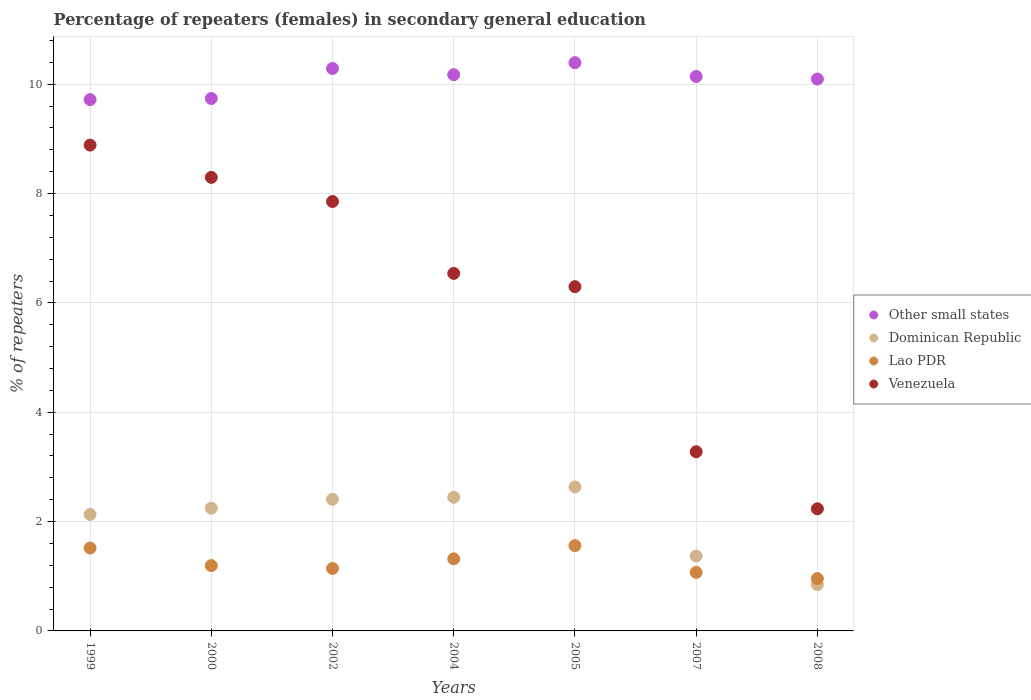How many different coloured dotlines are there?
Make the answer very short. 4. What is the percentage of female repeaters in Other small states in 2007?
Offer a terse response. 10.14. Across all years, what is the maximum percentage of female repeaters in Venezuela?
Your answer should be very brief. 8.89. Across all years, what is the minimum percentage of female repeaters in Lao PDR?
Ensure brevity in your answer.  0.96. In which year was the percentage of female repeaters in Dominican Republic maximum?
Keep it short and to the point. 2005. In which year was the percentage of female repeaters in Lao PDR minimum?
Provide a short and direct response. 2008. What is the total percentage of female repeaters in Dominican Republic in the graph?
Offer a terse response. 14.08. What is the difference between the percentage of female repeaters in Lao PDR in 1999 and that in 2007?
Your answer should be compact. 0.45. What is the difference between the percentage of female repeaters in Lao PDR in 2000 and the percentage of female repeaters in Dominican Republic in 2008?
Give a very brief answer. 0.35. What is the average percentage of female repeaters in Other small states per year?
Offer a very short reply. 10.08. In the year 1999, what is the difference between the percentage of female repeaters in Venezuela and percentage of female repeaters in Dominican Republic?
Your answer should be compact. 6.76. What is the ratio of the percentage of female repeaters in Dominican Republic in 2002 to that in 2004?
Give a very brief answer. 0.99. Is the percentage of female repeaters in Venezuela in 2000 less than that in 2005?
Your answer should be very brief. No. What is the difference between the highest and the second highest percentage of female repeaters in Other small states?
Your answer should be very brief. 0.11. What is the difference between the highest and the lowest percentage of female repeaters in Other small states?
Make the answer very short. 0.68. In how many years, is the percentage of female repeaters in Other small states greater than the average percentage of female repeaters in Other small states taken over all years?
Offer a terse response. 5. Is the sum of the percentage of female repeaters in Venezuela in 2002 and 2007 greater than the maximum percentage of female repeaters in Dominican Republic across all years?
Give a very brief answer. Yes. Is it the case that in every year, the sum of the percentage of female repeaters in Other small states and percentage of female repeaters in Lao PDR  is greater than the sum of percentage of female repeaters in Venezuela and percentage of female repeaters in Dominican Republic?
Your answer should be very brief. Yes. Is it the case that in every year, the sum of the percentage of female repeaters in Lao PDR and percentage of female repeaters in Dominican Republic  is greater than the percentage of female repeaters in Other small states?
Offer a terse response. No. Is the percentage of female repeaters in Venezuela strictly less than the percentage of female repeaters in Other small states over the years?
Ensure brevity in your answer.  Yes. How many years are there in the graph?
Your answer should be very brief. 7. Does the graph contain any zero values?
Your answer should be very brief. No. Does the graph contain grids?
Ensure brevity in your answer.  Yes. Where does the legend appear in the graph?
Provide a short and direct response. Center right. How are the legend labels stacked?
Make the answer very short. Vertical. What is the title of the graph?
Your answer should be very brief. Percentage of repeaters (females) in secondary general education. What is the label or title of the Y-axis?
Your answer should be compact. % of repeaters. What is the % of repeaters of Other small states in 1999?
Offer a terse response. 9.72. What is the % of repeaters in Dominican Republic in 1999?
Keep it short and to the point. 2.13. What is the % of repeaters in Lao PDR in 1999?
Ensure brevity in your answer.  1.52. What is the % of repeaters in Venezuela in 1999?
Make the answer very short. 8.89. What is the % of repeaters of Other small states in 2000?
Your response must be concise. 9.74. What is the % of repeaters in Dominican Republic in 2000?
Offer a terse response. 2.24. What is the % of repeaters of Lao PDR in 2000?
Ensure brevity in your answer.  1.2. What is the % of repeaters of Venezuela in 2000?
Provide a short and direct response. 8.3. What is the % of repeaters in Other small states in 2002?
Your response must be concise. 10.29. What is the % of repeaters of Dominican Republic in 2002?
Ensure brevity in your answer.  2.41. What is the % of repeaters of Lao PDR in 2002?
Offer a terse response. 1.14. What is the % of repeaters of Venezuela in 2002?
Make the answer very short. 7.85. What is the % of repeaters of Other small states in 2004?
Make the answer very short. 10.17. What is the % of repeaters of Dominican Republic in 2004?
Give a very brief answer. 2.44. What is the % of repeaters of Lao PDR in 2004?
Offer a very short reply. 1.32. What is the % of repeaters in Venezuela in 2004?
Offer a very short reply. 6.54. What is the % of repeaters of Other small states in 2005?
Your response must be concise. 10.39. What is the % of repeaters in Dominican Republic in 2005?
Provide a succinct answer. 2.63. What is the % of repeaters in Lao PDR in 2005?
Provide a succinct answer. 1.56. What is the % of repeaters of Venezuela in 2005?
Offer a terse response. 6.3. What is the % of repeaters of Other small states in 2007?
Ensure brevity in your answer.  10.14. What is the % of repeaters in Dominican Republic in 2007?
Provide a succinct answer. 1.37. What is the % of repeaters of Lao PDR in 2007?
Give a very brief answer. 1.07. What is the % of repeaters of Venezuela in 2007?
Offer a very short reply. 3.28. What is the % of repeaters of Other small states in 2008?
Offer a very short reply. 10.09. What is the % of repeaters of Dominican Republic in 2008?
Provide a succinct answer. 0.85. What is the % of repeaters in Lao PDR in 2008?
Make the answer very short. 0.96. What is the % of repeaters in Venezuela in 2008?
Make the answer very short. 2.23. Across all years, what is the maximum % of repeaters in Other small states?
Make the answer very short. 10.39. Across all years, what is the maximum % of repeaters in Dominican Republic?
Your response must be concise. 2.63. Across all years, what is the maximum % of repeaters in Lao PDR?
Ensure brevity in your answer.  1.56. Across all years, what is the maximum % of repeaters in Venezuela?
Keep it short and to the point. 8.89. Across all years, what is the minimum % of repeaters in Other small states?
Give a very brief answer. 9.72. Across all years, what is the minimum % of repeaters in Dominican Republic?
Offer a very short reply. 0.85. Across all years, what is the minimum % of repeaters in Lao PDR?
Your response must be concise. 0.96. Across all years, what is the minimum % of repeaters in Venezuela?
Your answer should be very brief. 2.23. What is the total % of repeaters in Other small states in the graph?
Give a very brief answer. 70.55. What is the total % of repeaters in Dominican Republic in the graph?
Offer a terse response. 14.08. What is the total % of repeaters of Lao PDR in the graph?
Keep it short and to the point. 8.76. What is the total % of repeaters in Venezuela in the graph?
Offer a very short reply. 43.38. What is the difference between the % of repeaters in Other small states in 1999 and that in 2000?
Your answer should be compact. -0.02. What is the difference between the % of repeaters in Dominican Republic in 1999 and that in 2000?
Offer a very short reply. -0.12. What is the difference between the % of repeaters in Lao PDR in 1999 and that in 2000?
Offer a terse response. 0.32. What is the difference between the % of repeaters in Venezuela in 1999 and that in 2000?
Offer a terse response. 0.59. What is the difference between the % of repeaters of Other small states in 1999 and that in 2002?
Your response must be concise. -0.57. What is the difference between the % of repeaters of Dominican Republic in 1999 and that in 2002?
Keep it short and to the point. -0.28. What is the difference between the % of repeaters of Lao PDR in 1999 and that in 2002?
Your answer should be very brief. 0.37. What is the difference between the % of repeaters of Venezuela in 1999 and that in 2002?
Your answer should be very brief. 1.03. What is the difference between the % of repeaters of Other small states in 1999 and that in 2004?
Offer a terse response. -0.46. What is the difference between the % of repeaters in Dominican Republic in 1999 and that in 2004?
Make the answer very short. -0.31. What is the difference between the % of repeaters in Lao PDR in 1999 and that in 2004?
Provide a succinct answer. 0.2. What is the difference between the % of repeaters in Venezuela in 1999 and that in 2004?
Offer a terse response. 2.35. What is the difference between the % of repeaters of Other small states in 1999 and that in 2005?
Offer a very short reply. -0.68. What is the difference between the % of repeaters in Dominican Republic in 1999 and that in 2005?
Your answer should be compact. -0.5. What is the difference between the % of repeaters in Lao PDR in 1999 and that in 2005?
Make the answer very short. -0.05. What is the difference between the % of repeaters in Venezuela in 1999 and that in 2005?
Offer a terse response. 2.59. What is the difference between the % of repeaters of Other small states in 1999 and that in 2007?
Offer a very short reply. -0.42. What is the difference between the % of repeaters in Dominican Republic in 1999 and that in 2007?
Offer a terse response. 0.76. What is the difference between the % of repeaters in Lao PDR in 1999 and that in 2007?
Give a very brief answer. 0.45. What is the difference between the % of repeaters in Venezuela in 1999 and that in 2007?
Your response must be concise. 5.61. What is the difference between the % of repeaters in Other small states in 1999 and that in 2008?
Your response must be concise. -0.38. What is the difference between the % of repeaters of Dominican Republic in 1999 and that in 2008?
Keep it short and to the point. 1.28. What is the difference between the % of repeaters in Lao PDR in 1999 and that in 2008?
Your answer should be compact. 0.56. What is the difference between the % of repeaters of Venezuela in 1999 and that in 2008?
Offer a terse response. 6.65. What is the difference between the % of repeaters of Other small states in 2000 and that in 2002?
Offer a terse response. -0.55. What is the difference between the % of repeaters in Dominican Republic in 2000 and that in 2002?
Make the answer very short. -0.16. What is the difference between the % of repeaters of Lao PDR in 2000 and that in 2002?
Provide a succinct answer. 0.05. What is the difference between the % of repeaters in Venezuela in 2000 and that in 2002?
Provide a short and direct response. 0.44. What is the difference between the % of repeaters of Other small states in 2000 and that in 2004?
Your answer should be very brief. -0.43. What is the difference between the % of repeaters in Dominican Republic in 2000 and that in 2004?
Make the answer very short. -0.2. What is the difference between the % of repeaters in Lao PDR in 2000 and that in 2004?
Offer a very short reply. -0.12. What is the difference between the % of repeaters of Venezuela in 2000 and that in 2004?
Offer a very short reply. 1.76. What is the difference between the % of repeaters of Other small states in 2000 and that in 2005?
Your answer should be compact. -0.65. What is the difference between the % of repeaters in Dominican Republic in 2000 and that in 2005?
Your answer should be very brief. -0.39. What is the difference between the % of repeaters in Lao PDR in 2000 and that in 2005?
Provide a succinct answer. -0.37. What is the difference between the % of repeaters of Venezuela in 2000 and that in 2005?
Offer a terse response. 2. What is the difference between the % of repeaters in Other small states in 2000 and that in 2007?
Offer a terse response. -0.4. What is the difference between the % of repeaters of Dominican Republic in 2000 and that in 2007?
Offer a very short reply. 0.87. What is the difference between the % of repeaters of Lao PDR in 2000 and that in 2007?
Provide a succinct answer. 0.13. What is the difference between the % of repeaters in Venezuela in 2000 and that in 2007?
Provide a short and direct response. 5.02. What is the difference between the % of repeaters of Other small states in 2000 and that in 2008?
Your answer should be compact. -0.36. What is the difference between the % of repeaters of Dominican Republic in 2000 and that in 2008?
Your answer should be compact. 1.4. What is the difference between the % of repeaters in Lao PDR in 2000 and that in 2008?
Provide a short and direct response. 0.24. What is the difference between the % of repeaters of Venezuela in 2000 and that in 2008?
Make the answer very short. 6.06. What is the difference between the % of repeaters of Other small states in 2002 and that in 2004?
Keep it short and to the point. 0.11. What is the difference between the % of repeaters in Dominican Republic in 2002 and that in 2004?
Your response must be concise. -0.04. What is the difference between the % of repeaters of Lao PDR in 2002 and that in 2004?
Your response must be concise. -0.18. What is the difference between the % of repeaters in Venezuela in 2002 and that in 2004?
Offer a terse response. 1.31. What is the difference between the % of repeaters of Other small states in 2002 and that in 2005?
Provide a succinct answer. -0.11. What is the difference between the % of repeaters of Dominican Republic in 2002 and that in 2005?
Provide a succinct answer. -0.23. What is the difference between the % of repeaters in Lao PDR in 2002 and that in 2005?
Keep it short and to the point. -0.42. What is the difference between the % of repeaters in Venezuela in 2002 and that in 2005?
Your answer should be very brief. 1.56. What is the difference between the % of repeaters in Other small states in 2002 and that in 2007?
Provide a short and direct response. 0.15. What is the difference between the % of repeaters in Dominican Republic in 2002 and that in 2007?
Make the answer very short. 1.04. What is the difference between the % of repeaters in Lao PDR in 2002 and that in 2007?
Provide a short and direct response. 0.07. What is the difference between the % of repeaters in Venezuela in 2002 and that in 2007?
Offer a terse response. 4.58. What is the difference between the % of repeaters of Other small states in 2002 and that in 2008?
Give a very brief answer. 0.19. What is the difference between the % of repeaters in Dominican Republic in 2002 and that in 2008?
Your answer should be compact. 1.56. What is the difference between the % of repeaters of Lao PDR in 2002 and that in 2008?
Give a very brief answer. 0.19. What is the difference between the % of repeaters of Venezuela in 2002 and that in 2008?
Your answer should be compact. 5.62. What is the difference between the % of repeaters of Other small states in 2004 and that in 2005?
Your answer should be very brief. -0.22. What is the difference between the % of repeaters of Dominican Republic in 2004 and that in 2005?
Keep it short and to the point. -0.19. What is the difference between the % of repeaters in Lao PDR in 2004 and that in 2005?
Offer a very short reply. -0.24. What is the difference between the % of repeaters in Venezuela in 2004 and that in 2005?
Your answer should be very brief. 0.24. What is the difference between the % of repeaters in Other small states in 2004 and that in 2007?
Provide a short and direct response. 0.03. What is the difference between the % of repeaters of Dominican Republic in 2004 and that in 2007?
Provide a succinct answer. 1.07. What is the difference between the % of repeaters of Lao PDR in 2004 and that in 2007?
Give a very brief answer. 0.25. What is the difference between the % of repeaters in Venezuela in 2004 and that in 2007?
Your response must be concise. 3.26. What is the difference between the % of repeaters of Other small states in 2004 and that in 2008?
Give a very brief answer. 0.08. What is the difference between the % of repeaters of Dominican Republic in 2004 and that in 2008?
Provide a short and direct response. 1.6. What is the difference between the % of repeaters in Lao PDR in 2004 and that in 2008?
Offer a very short reply. 0.36. What is the difference between the % of repeaters of Venezuela in 2004 and that in 2008?
Give a very brief answer. 4.31. What is the difference between the % of repeaters of Other small states in 2005 and that in 2007?
Keep it short and to the point. 0.25. What is the difference between the % of repeaters of Dominican Republic in 2005 and that in 2007?
Your response must be concise. 1.26. What is the difference between the % of repeaters in Lao PDR in 2005 and that in 2007?
Offer a very short reply. 0.49. What is the difference between the % of repeaters in Venezuela in 2005 and that in 2007?
Your answer should be very brief. 3.02. What is the difference between the % of repeaters in Other small states in 2005 and that in 2008?
Make the answer very short. 0.3. What is the difference between the % of repeaters in Dominican Republic in 2005 and that in 2008?
Offer a very short reply. 1.79. What is the difference between the % of repeaters in Lao PDR in 2005 and that in 2008?
Ensure brevity in your answer.  0.6. What is the difference between the % of repeaters in Venezuela in 2005 and that in 2008?
Give a very brief answer. 4.06. What is the difference between the % of repeaters in Other small states in 2007 and that in 2008?
Offer a terse response. 0.05. What is the difference between the % of repeaters of Dominican Republic in 2007 and that in 2008?
Provide a short and direct response. 0.52. What is the difference between the % of repeaters of Lao PDR in 2007 and that in 2008?
Offer a terse response. 0.11. What is the difference between the % of repeaters in Venezuela in 2007 and that in 2008?
Provide a short and direct response. 1.04. What is the difference between the % of repeaters in Other small states in 1999 and the % of repeaters in Dominican Republic in 2000?
Your answer should be very brief. 7.47. What is the difference between the % of repeaters in Other small states in 1999 and the % of repeaters in Lao PDR in 2000?
Provide a succinct answer. 8.52. What is the difference between the % of repeaters in Other small states in 1999 and the % of repeaters in Venezuela in 2000?
Make the answer very short. 1.42. What is the difference between the % of repeaters of Dominican Republic in 1999 and the % of repeaters of Lao PDR in 2000?
Your response must be concise. 0.93. What is the difference between the % of repeaters in Dominican Republic in 1999 and the % of repeaters in Venezuela in 2000?
Your answer should be very brief. -6.17. What is the difference between the % of repeaters in Lao PDR in 1999 and the % of repeaters in Venezuela in 2000?
Make the answer very short. -6.78. What is the difference between the % of repeaters in Other small states in 1999 and the % of repeaters in Dominican Republic in 2002?
Offer a very short reply. 7.31. What is the difference between the % of repeaters of Other small states in 1999 and the % of repeaters of Lao PDR in 2002?
Give a very brief answer. 8.58. What is the difference between the % of repeaters in Other small states in 1999 and the % of repeaters in Venezuela in 2002?
Your response must be concise. 1.86. What is the difference between the % of repeaters in Dominican Republic in 1999 and the % of repeaters in Lao PDR in 2002?
Ensure brevity in your answer.  0.99. What is the difference between the % of repeaters in Dominican Republic in 1999 and the % of repeaters in Venezuela in 2002?
Ensure brevity in your answer.  -5.72. What is the difference between the % of repeaters of Lao PDR in 1999 and the % of repeaters of Venezuela in 2002?
Provide a short and direct response. -6.34. What is the difference between the % of repeaters in Other small states in 1999 and the % of repeaters in Dominican Republic in 2004?
Make the answer very short. 7.27. What is the difference between the % of repeaters in Other small states in 1999 and the % of repeaters in Lao PDR in 2004?
Your answer should be compact. 8.4. What is the difference between the % of repeaters in Other small states in 1999 and the % of repeaters in Venezuela in 2004?
Provide a succinct answer. 3.18. What is the difference between the % of repeaters in Dominican Republic in 1999 and the % of repeaters in Lao PDR in 2004?
Your answer should be very brief. 0.81. What is the difference between the % of repeaters in Dominican Republic in 1999 and the % of repeaters in Venezuela in 2004?
Give a very brief answer. -4.41. What is the difference between the % of repeaters in Lao PDR in 1999 and the % of repeaters in Venezuela in 2004?
Give a very brief answer. -5.02. What is the difference between the % of repeaters in Other small states in 1999 and the % of repeaters in Dominican Republic in 2005?
Your answer should be compact. 7.08. What is the difference between the % of repeaters of Other small states in 1999 and the % of repeaters of Lao PDR in 2005?
Ensure brevity in your answer.  8.16. What is the difference between the % of repeaters of Other small states in 1999 and the % of repeaters of Venezuela in 2005?
Give a very brief answer. 3.42. What is the difference between the % of repeaters of Dominican Republic in 1999 and the % of repeaters of Lao PDR in 2005?
Your response must be concise. 0.57. What is the difference between the % of repeaters of Dominican Republic in 1999 and the % of repeaters of Venezuela in 2005?
Provide a succinct answer. -4.17. What is the difference between the % of repeaters of Lao PDR in 1999 and the % of repeaters of Venezuela in 2005?
Keep it short and to the point. -4.78. What is the difference between the % of repeaters in Other small states in 1999 and the % of repeaters in Dominican Republic in 2007?
Give a very brief answer. 8.35. What is the difference between the % of repeaters of Other small states in 1999 and the % of repeaters of Lao PDR in 2007?
Give a very brief answer. 8.65. What is the difference between the % of repeaters in Other small states in 1999 and the % of repeaters in Venezuela in 2007?
Ensure brevity in your answer.  6.44. What is the difference between the % of repeaters of Dominican Republic in 1999 and the % of repeaters of Lao PDR in 2007?
Give a very brief answer. 1.06. What is the difference between the % of repeaters in Dominican Republic in 1999 and the % of repeaters in Venezuela in 2007?
Make the answer very short. -1.15. What is the difference between the % of repeaters of Lao PDR in 1999 and the % of repeaters of Venezuela in 2007?
Provide a succinct answer. -1.76. What is the difference between the % of repeaters of Other small states in 1999 and the % of repeaters of Dominican Republic in 2008?
Your answer should be compact. 8.87. What is the difference between the % of repeaters of Other small states in 1999 and the % of repeaters of Lao PDR in 2008?
Your answer should be compact. 8.76. What is the difference between the % of repeaters in Other small states in 1999 and the % of repeaters in Venezuela in 2008?
Keep it short and to the point. 7.48. What is the difference between the % of repeaters of Dominican Republic in 1999 and the % of repeaters of Lao PDR in 2008?
Offer a terse response. 1.17. What is the difference between the % of repeaters of Dominican Republic in 1999 and the % of repeaters of Venezuela in 2008?
Your answer should be very brief. -0.1. What is the difference between the % of repeaters of Lao PDR in 1999 and the % of repeaters of Venezuela in 2008?
Make the answer very short. -0.72. What is the difference between the % of repeaters in Other small states in 2000 and the % of repeaters in Dominican Republic in 2002?
Keep it short and to the point. 7.33. What is the difference between the % of repeaters in Other small states in 2000 and the % of repeaters in Lao PDR in 2002?
Your response must be concise. 8.6. What is the difference between the % of repeaters in Other small states in 2000 and the % of repeaters in Venezuela in 2002?
Provide a succinct answer. 1.88. What is the difference between the % of repeaters of Dominican Republic in 2000 and the % of repeaters of Lao PDR in 2002?
Offer a terse response. 1.1. What is the difference between the % of repeaters in Dominican Republic in 2000 and the % of repeaters in Venezuela in 2002?
Your answer should be compact. -5.61. What is the difference between the % of repeaters in Lao PDR in 2000 and the % of repeaters in Venezuela in 2002?
Offer a very short reply. -6.66. What is the difference between the % of repeaters of Other small states in 2000 and the % of repeaters of Dominican Republic in 2004?
Offer a terse response. 7.29. What is the difference between the % of repeaters of Other small states in 2000 and the % of repeaters of Lao PDR in 2004?
Your answer should be compact. 8.42. What is the difference between the % of repeaters of Other small states in 2000 and the % of repeaters of Venezuela in 2004?
Keep it short and to the point. 3.2. What is the difference between the % of repeaters of Dominican Republic in 2000 and the % of repeaters of Lao PDR in 2004?
Your response must be concise. 0.93. What is the difference between the % of repeaters of Dominican Republic in 2000 and the % of repeaters of Venezuela in 2004?
Provide a succinct answer. -4.29. What is the difference between the % of repeaters of Lao PDR in 2000 and the % of repeaters of Venezuela in 2004?
Your answer should be very brief. -5.34. What is the difference between the % of repeaters of Other small states in 2000 and the % of repeaters of Dominican Republic in 2005?
Provide a short and direct response. 7.11. What is the difference between the % of repeaters in Other small states in 2000 and the % of repeaters in Lao PDR in 2005?
Ensure brevity in your answer.  8.18. What is the difference between the % of repeaters of Other small states in 2000 and the % of repeaters of Venezuela in 2005?
Provide a short and direct response. 3.44. What is the difference between the % of repeaters of Dominican Republic in 2000 and the % of repeaters of Lao PDR in 2005?
Your response must be concise. 0.68. What is the difference between the % of repeaters in Dominican Republic in 2000 and the % of repeaters in Venezuela in 2005?
Offer a terse response. -4.05. What is the difference between the % of repeaters of Lao PDR in 2000 and the % of repeaters of Venezuela in 2005?
Your answer should be very brief. -5.1. What is the difference between the % of repeaters in Other small states in 2000 and the % of repeaters in Dominican Republic in 2007?
Offer a terse response. 8.37. What is the difference between the % of repeaters of Other small states in 2000 and the % of repeaters of Lao PDR in 2007?
Provide a succinct answer. 8.67. What is the difference between the % of repeaters in Other small states in 2000 and the % of repeaters in Venezuela in 2007?
Keep it short and to the point. 6.46. What is the difference between the % of repeaters in Dominican Republic in 2000 and the % of repeaters in Lao PDR in 2007?
Offer a terse response. 1.17. What is the difference between the % of repeaters of Dominican Republic in 2000 and the % of repeaters of Venezuela in 2007?
Keep it short and to the point. -1.03. What is the difference between the % of repeaters in Lao PDR in 2000 and the % of repeaters in Venezuela in 2007?
Your response must be concise. -2.08. What is the difference between the % of repeaters in Other small states in 2000 and the % of repeaters in Dominican Republic in 2008?
Your response must be concise. 8.89. What is the difference between the % of repeaters in Other small states in 2000 and the % of repeaters in Lao PDR in 2008?
Your answer should be very brief. 8.78. What is the difference between the % of repeaters of Other small states in 2000 and the % of repeaters of Venezuela in 2008?
Your response must be concise. 7.51. What is the difference between the % of repeaters in Dominican Republic in 2000 and the % of repeaters in Lao PDR in 2008?
Your answer should be very brief. 1.29. What is the difference between the % of repeaters of Dominican Republic in 2000 and the % of repeaters of Venezuela in 2008?
Offer a very short reply. 0.01. What is the difference between the % of repeaters in Lao PDR in 2000 and the % of repeaters in Venezuela in 2008?
Your answer should be compact. -1.04. What is the difference between the % of repeaters in Other small states in 2002 and the % of repeaters in Dominican Republic in 2004?
Make the answer very short. 7.84. What is the difference between the % of repeaters in Other small states in 2002 and the % of repeaters in Lao PDR in 2004?
Your answer should be very brief. 8.97. What is the difference between the % of repeaters of Other small states in 2002 and the % of repeaters of Venezuela in 2004?
Your answer should be compact. 3.75. What is the difference between the % of repeaters of Dominican Republic in 2002 and the % of repeaters of Lao PDR in 2004?
Keep it short and to the point. 1.09. What is the difference between the % of repeaters of Dominican Republic in 2002 and the % of repeaters of Venezuela in 2004?
Provide a succinct answer. -4.13. What is the difference between the % of repeaters in Lao PDR in 2002 and the % of repeaters in Venezuela in 2004?
Your answer should be compact. -5.4. What is the difference between the % of repeaters of Other small states in 2002 and the % of repeaters of Dominican Republic in 2005?
Ensure brevity in your answer.  7.65. What is the difference between the % of repeaters of Other small states in 2002 and the % of repeaters of Lao PDR in 2005?
Provide a short and direct response. 8.73. What is the difference between the % of repeaters of Other small states in 2002 and the % of repeaters of Venezuela in 2005?
Offer a terse response. 3.99. What is the difference between the % of repeaters of Dominican Republic in 2002 and the % of repeaters of Lao PDR in 2005?
Keep it short and to the point. 0.85. What is the difference between the % of repeaters in Dominican Republic in 2002 and the % of repeaters in Venezuela in 2005?
Make the answer very short. -3.89. What is the difference between the % of repeaters of Lao PDR in 2002 and the % of repeaters of Venezuela in 2005?
Make the answer very short. -5.15. What is the difference between the % of repeaters of Other small states in 2002 and the % of repeaters of Dominican Republic in 2007?
Ensure brevity in your answer.  8.92. What is the difference between the % of repeaters in Other small states in 2002 and the % of repeaters in Lao PDR in 2007?
Make the answer very short. 9.22. What is the difference between the % of repeaters of Other small states in 2002 and the % of repeaters of Venezuela in 2007?
Keep it short and to the point. 7.01. What is the difference between the % of repeaters of Dominican Republic in 2002 and the % of repeaters of Lao PDR in 2007?
Provide a short and direct response. 1.34. What is the difference between the % of repeaters of Dominican Republic in 2002 and the % of repeaters of Venezuela in 2007?
Offer a terse response. -0.87. What is the difference between the % of repeaters in Lao PDR in 2002 and the % of repeaters in Venezuela in 2007?
Keep it short and to the point. -2.13. What is the difference between the % of repeaters of Other small states in 2002 and the % of repeaters of Dominican Republic in 2008?
Ensure brevity in your answer.  9.44. What is the difference between the % of repeaters in Other small states in 2002 and the % of repeaters in Lao PDR in 2008?
Offer a very short reply. 9.33. What is the difference between the % of repeaters of Other small states in 2002 and the % of repeaters of Venezuela in 2008?
Your answer should be very brief. 8.05. What is the difference between the % of repeaters in Dominican Republic in 2002 and the % of repeaters in Lao PDR in 2008?
Offer a very short reply. 1.45. What is the difference between the % of repeaters of Dominican Republic in 2002 and the % of repeaters of Venezuela in 2008?
Provide a succinct answer. 0.17. What is the difference between the % of repeaters in Lao PDR in 2002 and the % of repeaters in Venezuela in 2008?
Provide a short and direct response. -1.09. What is the difference between the % of repeaters in Other small states in 2004 and the % of repeaters in Dominican Republic in 2005?
Your response must be concise. 7.54. What is the difference between the % of repeaters of Other small states in 2004 and the % of repeaters of Lao PDR in 2005?
Offer a very short reply. 8.61. What is the difference between the % of repeaters of Other small states in 2004 and the % of repeaters of Venezuela in 2005?
Your answer should be compact. 3.88. What is the difference between the % of repeaters in Dominican Republic in 2004 and the % of repeaters in Lao PDR in 2005?
Your answer should be compact. 0.88. What is the difference between the % of repeaters in Dominican Republic in 2004 and the % of repeaters in Venezuela in 2005?
Ensure brevity in your answer.  -3.85. What is the difference between the % of repeaters in Lao PDR in 2004 and the % of repeaters in Venezuela in 2005?
Offer a terse response. -4.98. What is the difference between the % of repeaters of Other small states in 2004 and the % of repeaters of Dominican Republic in 2007?
Provide a short and direct response. 8.8. What is the difference between the % of repeaters of Other small states in 2004 and the % of repeaters of Lao PDR in 2007?
Keep it short and to the point. 9.1. What is the difference between the % of repeaters in Other small states in 2004 and the % of repeaters in Venezuela in 2007?
Provide a short and direct response. 6.9. What is the difference between the % of repeaters of Dominican Republic in 2004 and the % of repeaters of Lao PDR in 2007?
Ensure brevity in your answer.  1.37. What is the difference between the % of repeaters of Dominican Republic in 2004 and the % of repeaters of Venezuela in 2007?
Provide a succinct answer. -0.83. What is the difference between the % of repeaters in Lao PDR in 2004 and the % of repeaters in Venezuela in 2007?
Your answer should be compact. -1.96. What is the difference between the % of repeaters of Other small states in 2004 and the % of repeaters of Dominican Republic in 2008?
Offer a very short reply. 9.33. What is the difference between the % of repeaters of Other small states in 2004 and the % of repeaters of Lao PDR in 2008?
Offer a terse response. 9.22. What is the difference between the % of repeaters of Other small states in 2004 and the % of repeaters of Venezuela in 2008?
Your answer should be compact. 7.94. What is the difference between the % of repeaters in Dominican Republic in 2004 and the % of repeaters in Lao PDR in 2008?
Ensure brevity in your answer.  1.49. What is the difference between the % of repeaters of Dominican Republic in 2004 and the % of repeaters of Venezuela in 2008?
Offer a terse response. 0.21. What is the difference between the % of repeaters of Lao PDR in 2004 and the % of repeaters of Venezuela in 2008?
Your response must be concise. -0.92. What is the difference between the % of repeaters of Other small states in 2005 and the % of repeaters of Dominican Republic in 2007?
Offer a very short reply. 9.02. What is the difference between the % of repeaters of Other small states in 2005 and the % of repeaters of Lao PDR in 2007?
Provide a short and direct response. 9.32. What is the difference between the % of repeaters in Other small states in 2005 and the % of repeaters in Venezuela in 2007?
Your answer should be very brief. 7.12. What is the difference between the % of repeaters in Dominican Republic in 2005 and the % of repeaters in Lao PDR in 2007?
Offer a very short reply. 1.56. What is the difference between the % of repeaters in Dominican Republic in 2005 and the % of repeaters in Venezuela in 2007?
Your response must be concise. -0.64. What is the difference between the % of repeaters of Lao PDR in 2005 and the % of repeaters of Venezuela in 2007?
Your answer should be compact. -1.72. What is the difference between the % of repeaters of Other small states in 2005 and the % of repeaters of Dominican Republic in 2008?
Keep it short and to the point. 9.55. What is the difference between the % of repeaters in Other small states in 2005 and the % of repeaters in Lao PDR in 2008?
Ensure brevity in your answer.  9.44. What is the difference between the % of repeaters of Other small states in 2005 and the % of repeaters of Venezuela in 2008?
Your answer should be very brief. 8.16. What is the difference between the % of repeaters of Dominican Republic in 2005 and the % of repeaters of Lao PDR in 2008?
Give a very brief answer. 1.68. What is the difference between the % of repeaters in Lao PDR in 2005 and the % of repeaters in Venezuela in 2008?
Make the answer very short. -0.67. What is the difference between the % of repeaters of Other small states in 2007 and the % of repeaters of Dominican Republic in 2008?
Provide a succinct answer. 9.29. What is the difference between the % of repeaters in Other small states in 2007 and the % of repeaters in Lao PDR in 2008?
Ensure brevity in your answer.  9.18. What is the difference between the % of repeaters of Other small states in 2007 and the % of repeaters of Venezuela in 2008?
Offer a terse response. 7.91. What is the difference between the % of repeaters of Dominican Republic in 2007 and the % of repeaters of Lao PDR in 2008?
Ensure brevity in your answer.  0.41. What is the difference between the % of repeaters of Dominican Republic in 2007 and the % of repeaters of Venezuela in 2008?
Provide a short and direct response. -0.86. What is the difference between the % of repeaters in Lao PDR in 2007 and the % of repeaters in Venezuela in 2008?
Offer a very short reply. -1.16. What is the average % of repeaters in Other small states per year?
Make the answer very short. 10.08. What is the average % of repeaters in Dominican Republic per year?
Offer a very short reply. 2.01. What is the average % of repeaters in Lao PDR per year?
Your answer should be very brief. 1.25. What is the average % of repeaters in Venezuela per year?
Your answer should be compact. 6.2. In the year 1999, what is the difference between the % of repeaters of Other small states and % of repeaters of Dominican Republic?
Provide a short and direct response. 7.59. In the year 1999, what is the difference between the % of repeaters of Other small states and % of repeaters of Lao PDR?
Give a very brief answer. 8.2. In the year 1999, what is the difference between the % of repeaters in Other small states and % of repeaters in Venezuela?
Provide a succinct answer. 0.83. In the year 1999, what is the difference between the % of repeaters of Dominican Republic and % of repeaters of Lao PDR?
Make the answer very short. 0.61. In the year 1999, what is the difference between the % of repeaters of Dominican Republic and % of repeaters of Venezuela?
Give a very brief answer. -6.76. In the year 1999, what is the difference between the % of repeaters in Lao PDR and % of repeaters in Venezuela?
Offer a very short reply. -7.37. In the year 2000, what is the difference between the % of repeaters of Other small states and % of repeaters of Dominican Republic?
Ensure brevity in your answer.  7.49. In the year 2000, what is the difference between the % of repeaters of Other small states and % of repeaters of Lao PDR?
Ensure brevity in your answer.  8.54. In the year 2000, what is the difference between the % of repeaters in Other small states and % of repeaters in Venezuela?
Your answer should be compact. 1.44. In the year 2000, what is the difference between the % of repeaters of Dominican Republic and % of repeaters of Lao PDR?
Ensure brevity in your answer.  1.05. In the year 2000, what is the difference between the % of repeaters in Dominican Republic and % of repeaters in Venezuela?
Ensure brevity in your answer.  -6.05. In the year 2000, what is the difference between the % of repeaters in Lao PDR and % of repeaters in Venezuela?
Provide a short and direct response. -7.1. In the year 2002, what is the difference between the % of repeaters in Other small states and % of repeaters in Dominican Republic?
Keep it short and to the point. 7.88. In the year 2002, what is the difference between the % of repeaters in Other small states and % of repeaters in Lao PDR?
Offer a terse response. 9.14. In the year 2002, what is the difference between the % of repeaters in Other small states and % of repeaters in Venezuela?
Your response must be concise. 2.43. In the year 2002, what is the difference between the % of repeaters in Dominican Republic and % of repeaters in Lao PDR?
Provide a succinct answer. 1.26. In the year 2002, what is the difference between the % of repeaters of Dominican Republic and % of repeaters of Venezuela?
Your answer should be very brief. -5.45. In the year 2002, what is the difference between the % of repeaters in Lao PDR and % of repeaters in Venezuela?
Provide a short and direct response. -6.71. In the year 2004, what is the difference between the % of repeaters of Other small states and % of repeaters of Dominican Republic?
Provide a short and direct response. 7.73. In the year 2004, what is the difference between the % of repeaters of Other small states and % of repeaters of Lao PDR?
Make the answer very short. 8.85. In the year 2004, what is the difference between the % of repeaters of Other small states and % of repeaters of Venezuela?
Your response must be concise. 3.63. In the year 2004, what is the difference between the % of repeaters of Dominican Republic and % of repeaters of Lao PDR?
Your answer should be very brief. 1.13. In the year 2004, what is the difference between the % of repeaters in Dominican Republic and % of repeaters in Venezuela?
Provide a short and direct response. -4.1. In the year 2004, what is the difference between the % of repeaters in Lao PDR and % of repeaters in Venezuela?
Your answer should be very brief. -5.22. In the year 2005, what is the difference between the % of repeaters of Other small states and % of repeaters of Dominican Republic?
Ensure brevity in your answer.  7.76. In the year 2005, what is the difference between the % of repeaters in Other small states and % of repeaters in Lao PDR?
Give a very brief answer. 8.83. In the year 2005, what is the difference between the % of repeaters in Other small states and % of repeaters in Venezuela?
Your response must be concise. 4.1. In the year 2005, what is the difference between the % of repeaters of Dominican Republic and % of repeaters of Lao PDR?
Ensure brevity in your answer.  1.07. In the year 2005, what is the difference between the % of repeaters of Dominican Republic and % of repeaters of Venezuela?
Give a very brief answer. -3.66. In the year 2005, what is the difference between the % of repeaters in Lao PDR and % of repeaters in Venezuela?
Keep it short and to the point. -4.74. In the year 2007, what is the difference between the % of repeaters of Other small states and % of repeaters of Dominican Republic?
Provide a succinct answer. 8.77. In the year 2007, what is the difference between the % of repeaters in Other small states and % of repeaters in Lao PDR?
Ensure brevity in your answer.  9.07. In the year 2007, what is the difference between the % of repeaters of Other small states and % of repeaters of Venezuela?
Provide a succinct answer. 6.86. In the year 2007, what is the difference between the % of repeaters of Dominican Republic and % of repeaters of Lao PDR?
Your response must be concise. 0.3. In the year 2007, what is the difference between the % of repeaters of Dominican Republic and % of repeaters of Venezuela?
Give a very brief answer. -1.91. In the year 2007, what is the difference between the % of repeaters in Lao PDR and % of repeaters in Venezuela?
Provide a short and direct response. -2.21. In the year 2008, what is the difference between the % of repeaters of Other small states and % of repeaters of Dominican Republic?
Provide a short and direct response. 9.25. In the year 2008, what is the difference between the % of repeaters of Other small states and % of repeaters of Lao PDR?
Give a very brief answer. 9.14. In the year 2008, what is the difference between the % of repeaters of Other small states and % of repeaters of Venezuela?
Your answer should be very brief. 7.86. In the year 2008, what is the difference between the % of repeaters of Dominican Republic and % of repeaters of Lao PDR?
Your answer should be compact. -0.11. In the year 2008, what is the difference between the % of repeaters of Dominican Republic and % of repeaters of Venezuela?
Offer a very short reply. -1.39. In the year 2008, what is the difference between the % of repeaters of Lao PDR and % of repeaters of Venezuela?
Offer a very short reply. -1.28. What is the ratio of the % of repeaters in Dominican Republic in 1999 to that in 2000?
Your answer should be compact. 0.95. What is the ratio of the % of repeaters in Lao PDR in 1999 to that in 2000?
Provide a succinct answer. 1.27. What is the ratio of the % of repeaters in Venezuela in 1999 to that in 2000?
Your response must be concise. 1.07. What is the ratio of the % of repeaters in Other small states in 1999 to that in 2002?
Provide a succinct answer. 0.94. What is the ratio of the % of repeaters in Dominican Republic in 1999 to that in 2002?
Your response must be concise. 0.88. What is the ratio of the % of repeaters of Lao PDR in 1999 to that in 2002?
Your answer should be compact. 1.33. What is the ratio of the % of repeaters in Venezuela in 1999 to that in 2002?
Ensure brevity in your answer.  1.13. What is the ratio of the % of repeaters in Other small states in 1999 to that in 2004?
Keep it short and to the point. 0.96. What is the ratio of the % of repeaters of Dominican Republic in 1999 to that in 2004?
Give a very brief answer. 0.87. What is the ratio of the % of repeaters of Lao PDR in 1999 to that in 2004?
Your response must be concise. 1.15. What is the ratio of the % of repeaters of Venezuela in 1999 to that in 2004?
Provide a short and direct response. 1.36. What is the ratio of the % of repeaters of Other small states in 1999 to that in 2005?
Your response must be concise. 0.94. What is the ratio of the % of repeaters in Dominican Republic in 1999 to that in 2005?
Provide a short and direct response. 0.81. What is the ratio of the % of repeaters in Lao PDR in 1999 to that in 2005?
Offer a terse response. 0.97. What is the ratio of the % of repeaters in Venezuela in 1999 to that in 2005?
Provide a succinct answer. 1.41. What is the ratio of the % of repeaters in Dominican Republic in 1999 to that in 2007?
Your answer should be very brief. 1.55. What is the ratio of the % of repeaters in Lao PDR in 1999 to that in 2007?
Your response must be concise. 1.42. What is the ratio of the % of repeaters of Venezuela in 1999 to that in 2007?
Your answer should be compact. 2.71. What is the ratio of the % of repeaters of Other small states in 1999 to that in 2008?
Offer a very short reply. 0.96. What is the ratio of the % of repeaters in Dominican Republic in 1999 to that in 2008?
Ensure brevity in your answer.  2.52. What is the ratio of the % of repeaters of Lao PDR in 1999 to that in 2008?
Make the answer very short. 1.58. What is the ratio of the % of repeaters of Venezuela in 1999 to that in 2008?
Your answer should be very brief. 3.98. What is the ratio of the % of repeaters in Other small states in 2000 to that in 2002?
Your response must be concise. 0.95. What is the ratio of the % of repeaters in Dominican Republic in 2000 to that in 2002?
Make the answer very short. 0.93. What is the ratio of the % of repeaters of Lao PDR in 2000 to that in 2002?
Provide a short and direct response. 1.05. What is the ratio of the % of repeaters in Venezuela in 2000 to that in 2002?
Ensure brevity in your answer.  1.06. What is the ratio of the % of repeaters of Other small states in 2000 to that in 2004?
Ensure brevity in your answer.  0.96. What is the ratio of the % of repeaters of Dominican Republic in 2000 to that in 2004?
Your answer should be compact. 0.92. What is the ratio of the % of repeaters in Lao PDR in 2000 to that in 2004?
Make the answer very short. 0.91. What is the ratio of the % of repeaters of Venezuela in 2000 to that in 2004?
Your answer should be compact. 1.27. What is the ratio of the % of repeaters in Other small states in 2000 to that in 2005?
Your answer should be compact. 0.94. What is the ratio of the % of repeaters of Dominican Republic in 2000 to that in 2005?
Offer a very short reply. 0.85. What is the ratio of the % of repeaters in Lao PDR in 2000 to that in 2005?
Your answer should be very brief. 0.77. What is the ratio of the % of repeaters of Venezuela in 2000 to that in 2005?
Provide a succinct answer. 1.32. What is the ratio of the % of repeaters of Other small states in 2000 to that in 2007?
Provide a succinct answer. 0.96. What is the ratio of the % of repeaters in Dominican Republic in 2000 to that in 2007?
Provide a short and direct response. 1.64. What is the ratio of the % of repeaters of Lao PDR in 2000 to that in 2007?
Provide a short and direct response. 1.12. What is the ratio of the % of repeaters in Venezuela in 2000 to that in 2007?
Ensure brevity in your answer.  2.53. What is the ratio of the % of repeaters in Other small states in 2000 to that in 2008?
Offer a terse response. 0.96. What is the ratio of the % of repeaters of Dominican Republic in 2000 to that in 2008?
Ensure brevity in your answer.  2.65. What is the ratio of the % of repeaters of Lao PDR in 2000 to that in 2008?
Offer a very short reply. 1.25. What is the ratio of the % of repeaters of Venezuela in 2000 to that in 2008?
Your answer should be compact. 3.71. What is the ratio of the % of repeaters of Other small states in 2002 to that in 2004?
Offer a very short reply. 1.01. What is the ratio of the % of repeaters of Dominican Republic in 2002 to that in 2004?
Keep it short and to the point. 0.99. What is the ratio of the % of repeaters in Lao PDR in 2002 to that in 2004?
Keep it short and to the point. 0.87. What is the ratio of the % of repeaters in Venezuela in 2002 to that in 2004?
Make the answer very short. 1.2. What is the ratio of the % of repeaters of Other small states in 2002 to that in 2005?
Give a very brief answer. 0.99. What is the ratio of the % of repeaters of Dominican Republic in 2002 to that in 2005?
Your response must be concise. 0.91. What is the ratio of the % of repeaters of Lao PDR in 2002 to that in 2005?
Ensure brevity in your answer.  0.73. What is the ratio of the % of repeaters in Venezuela in 2002 to that in 2005?
Provide a short and direct response. 1.25. What is the ratio of the % of repeaters in Other small states in 2002 to that in 2007?
Offer a terse response. 1.01. What is the ratio of the % of repeaters in Dominican Republic in 2002 to that in 2007?
Offer a very short reply. 1.76. What is the ratio of the % of repeaters of Lao PDR in 2002 to that in 2007?
Offer a terse response. 1.07. What is the ratio of the % of repeaters of Venezuela in 2002 to that in 2007?
Your answer should be very brief. 2.4. What is the ratio of the % of repeaters of Other small states in 2002 to that in 2008?
Ensure brevity in your answer.  1.02. What is the ratio of the % of repeaters in Dominican Republic in 2002 to that in 2008?
Your answer should be very brief. 2.84. What is the ratio of the % of repeaters in Lao PDR in 2002 to that in 2008?
Make the answer very short. 1.19. What is the ratio of the % of repeaters of Venezuela in 2002 to that in 2008?
Make the answer very short. 3.52. What is the ratio of the % of repeaters of Other small states in 2004 to that in 2005?
Your answer should be compact. 0.98. What is the ratio of the % of repeaters in Dominican Republic in 2004 to that in 2005?
Ensure brevity in your answer.  0.93. What is the ratio of the % of repeaters in Lao PDR in 2004 to that in 2005?
Give a very brief answer. 0.84. What is the ratio of the % of repeaters in Venezuela in 2004 to that in 2005?
Ensure brevity in your answer.  1.04. What is the ratio of the % of repeaters of Dominican Republic in 2004 to that in 2007?
Offer a very short reply. 1.78. What is the ratio of the % of repeaters of Lao PDR in 2004 to that in 2007?
Make the answer very short. 1.23. What is the ratio of the % of repeaters in Venezuela in 2004 to that in 2007?
Offer a very short reply. 2. What is the ratio of the % of repeaters of Other small states in 2004 to that in 2008?
Provide a succinct answer. 1.01. What is the ratio of the % of repeaters in Dominican Republic in 2004 to that in 2008?
Keep it short and to the point. 2.89. What is the ratio of the % of repeaters in Lao PDR in 2004 to that in 2008?
Your response must be concise. 1.38. What is the ratio of the % of repeaters of Venezuela in 2004 to that in 2008?
Your response must be concise. 2.93. What is the ratio of the % of repeaters in Other small states in 2005 to that in 2007?
Give a very brief answer. 1.02. What is the ratio of the % of repeaters of Dominican Republic in 2005 to that in 2007?
Your answer should be compact. 1.92. What is the ratio of the % of repeaters in Lao PDR in 2005 to that in 2007?
Your response must be concise. 1.46. What is the ratio of the % of repeaters in Venezuela in 2005 to that in 2007?
Provide a succinct answer. 1.92. What is the ratio of the % of repeaters in Other small states in 2005 to that in 2008?
Your answer should be very brief. 1.03. What is the ratio of the % of repeaters of Dominican Republic in 2005 to that in 2008?
Offer a terse response. 3.11. What is the ratio of the % of repeaters in Lao PDR in 2005 to that in 2008?
Give a very brief answer. 1.63. What is the ratio of the % of repeaters of Venezuela in 2005 to that in 2008?
Provide a succinct answer. 2.82. What is the ratio of the % of repeaters in Other small states in 2007 to that in 2008?
Offer a terse response. 1. What is the ratio of the % of repeaters in Dominican Republic in 2007 to that in 2008?
Your answer should be compact. 1.62. What is the ratio of the % of repeaters of Lao PDR in 2007 to that in 2008?
Ensure brevity in your answer.  1.12. What is the ratio of the % of repeaters in Venezuela in 2007 to that in 2008?
Your answer should be very brief. 1.47. What is the difference between the highest and the second highest % of repeaters in Other small states?
Keep it short and to the point. 0.11. What is the difference between the highest and the second highest % of repeaters in Dominican Republic?
Keep it short and to the point. 0.19. What is the difference between the highest and the second highest % of repeaters in Lao PDR?
Provide a short and direct response. 0.05. What is the difference between the highest and the second highest % of repeaters in Venezuela?
Give a very brief answer. 0.59. What is the difference between the highest and the lowest % of repeaters of Other small states?
Your answer should be very brief. 0.68. What is the difference between the highest and the lowest % of repeaters of Dominican Republic?
Offer a terse response. 1.79. What is the difference between the highest and the lowest % of repeaters in Lao PDR?
Your answer should be very brief. 0.6. What is the difference between the highest and the lowest % of repeaters of Venezuela?
Your answer should be very brief. 6.65. 